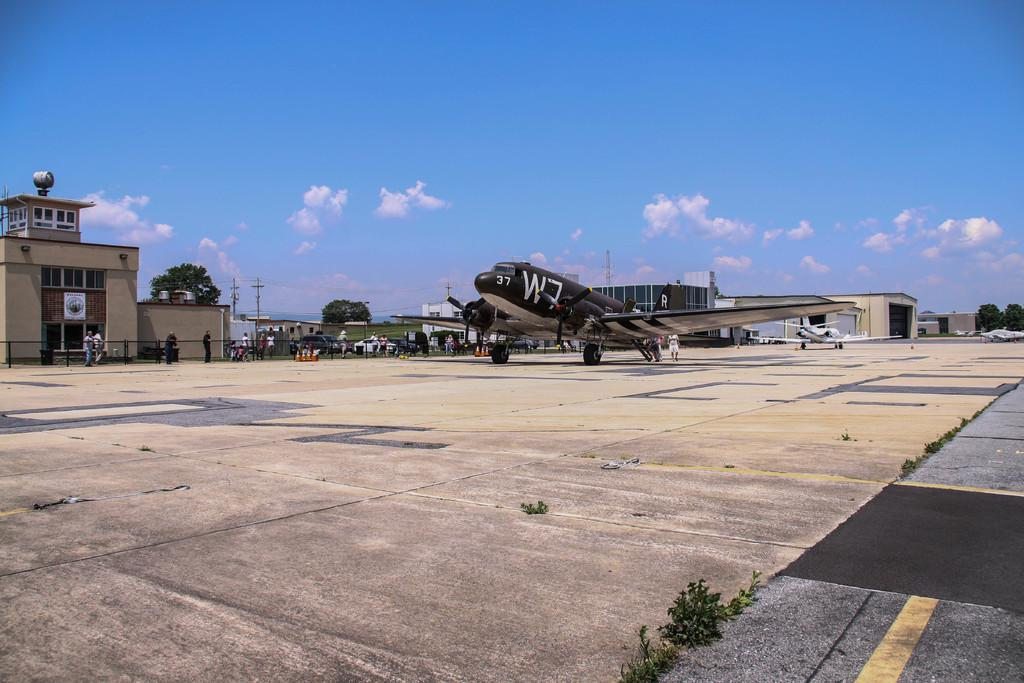Provide a one-sentence caption for the provided image. A large propeller plane has the number 37 on it's nose. 